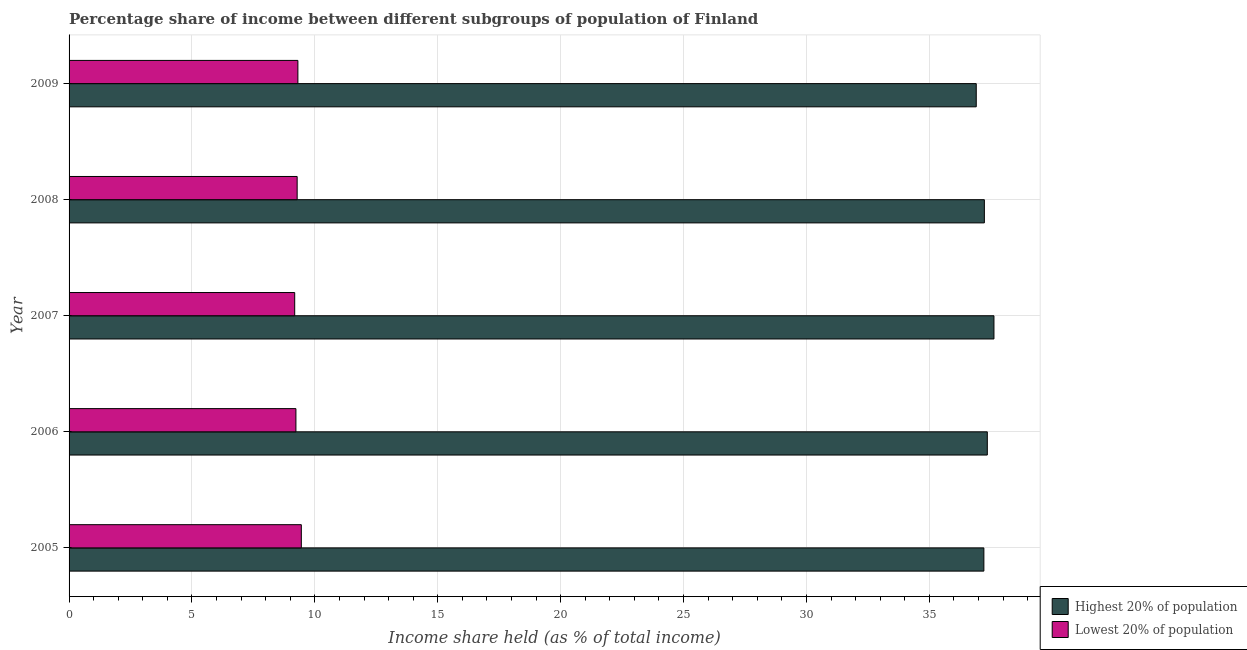What is the income share held by lowest 20% of the population in 2008?
Your answer should be very brief. 9.28. Across all years, what is the maximum income share held by lowest 20% of the population?
Offer a very short reply. 9.45. Across all years, what is the minimum income share held by highest 20% of the population?
Give a very brief answer. 36.91. In which year was the income share held by highest 20% of the population maximum?
Your answer should be compact. 2007. In which year was the income share held by highest 20% of the population minimum?
Keep it short and to the point. 2009. What is the total income share held by highest 20% of the population in the graph?
Your answer should be compact. 186.36. What is the difference between the income share held by highest 20% of the population in 2007 and that in 2008?
Your answer should be compact. 0.39. What is the difference between the income share held by lowest 20% of the population in 2006 and the income share held by highest 20% of the population in 2007?
Provide a short and direct response. -28.4. What is the average income share held by lowest 20% of the population per year?
Your answer should be compact. 9.29. In the year 2005, what is the difference between the income share held by highest 20% of the population and income share held by lowest 20% of the population?
Your answer should be compact. 27.77. What is the ratio of the income share held by lowest 20% of the population in 2006 to that in 2009?
Keep it short and to the point. 0.99. What is the difference between the highest and the second highest income share held by highest 20% of the population?
Offer a very short reply. 0.27. What is the difference between the highest and the lowest income share held by highest 20% of the population?
Your answer should be very brief. 0.72. In how many years, is the income share held by highest 20% of the population greater than the average income share held by highest 20% of the population taken over all years?
Make the answer very short. 2. What does the 2nd bar from the top in 2005 represents?
Offer a terse response. Highest 20% of population. What does the 2nd bar from the bottom in 2006 represents?
Give a very brief answer. Lowest 20% of population. How many years are there in the graph?
Offer a very short reply. 5. Does the graph contain grids?
Provide a short and direct response. Yes. How many legend labels are there?
Make the answer very short. 2. How are the legend labels stacked?
Give a very brief answer. Vertical. What is the title of the graph?
Provide a short and direct response. Percentage share of income between different subgroups of population of Finland. Does "Unregistered firms" appear as one of the legend labels in the graph?
Offer a terse response. No. What is the label or title of the X-axis?
Offer a very short reply. Income share held (as % of total income). What is the label or title of the Y-axis?
Your response must be concise. Year. What is the Income share held (as % of total income) in Highest 20% of population in 2005?
Ensure brevity in your answer.  37.22. What is the Income share held (as % of total income) of Lowest 20% of population in 2005?
Offer a terse response. 9.45. What is the Income share held (as % of total income) in Highest 20% of population in 2006?
Provide a short and direct response. 37.36. What is the Income share held (as % of total income) of Lowest 20% of population in 2006?
Offer a very short reply. 9.23. What is the Income share held (as % of total income) of Highest 20% of population in 2007?
Your response must be concise. 37.63. What is the Income share held (as % of total income) in Lowest 20% of population in 2007?
Give a very brief answer. 9.18. What is the Income share held (as % of total income) of Highest 20% of population in 2008?
Offer a terse response. 37.24. What is the Income share held (as % of total income) of Lowest 20% of population in 2008?
Provide a short and direct response. 9.28. What is the Income share held (as % of total income) of Highest 20% of population in 2009?
Offer a terse response. 36.91. What is the Income share held (as % of total income) of Lowest 20% of population in 2009?
Keep it short and to the point. 9.31. Across all years, what is the maximum Income share held (as % of total income) of Highest 20% of population?
Give a very brief answer. 37.63. Across all years, what is the maximum Income share held (as % of total income) in Lowest 20% of population?
Provide a short and direct response. 9.45. Across all years, what is the minimum Income share held (as % of total income) in Highest 20% of population?
Provide a succinct answer. 36.91. Across all years, what is the minimum Income share held (as % of total income) in Lowest 20% of population?
Offer a terse response. 9.18. What is the total Income share held (as % of total income) of Highest 20% of population in the graph?
Offer a very short reply. 186.36. What is the total Income share held (as % of total income) of Lowest 20% of population in the graph?
Ensure brevity in your answer.  46.45. What is the difference between the Income share held (as % of total income) in Highest 20% of population in 2005 and that in 2006?
Give a very brief answer. -0.14. What is the difference between the Income share held (as % of total income) of Lowest 20% of population in 2005 and that in 2006?
Give a very brief answer. 0.22. What is the difference between the Income share held (as % of total income) of Highest 20% of population in 2005 and that in 2007?
Offer a very short reply. -0.41. What is the difference between the Income share held (as % of total income) of Lowest 20% of population in 2005 and that in 2007?
Provide a succinct answer. 0.27. What is the difference between the Income share held (as % of total income) in Highest 20% of population in 2005 and that in 2008?
Provide a succinct answer. -0.02. What is the difference between the Income share held (as % of total income) of Lowest 20% of population in 2005 and that in 2008?
Provide a succinct answer. 0.17. What is the difference between the Income share held (as % of total income) of Highest 20% of population in 2005 and that in 2009?
Ensure brevity in your answer.  0.31. What is the difference between the Income share held (as % of total income) of Lowest 20% of population in 2005 and that in 2009?
Give a very brief answer. 0.14. What is the difference between the Income share held (as % of total income) of Highest 20% of population in 2006 and that in 2007?
Give a very brief answer. -0.27. What is the difference between the Income share held (as % of total income) in Highest 20% of population in 2006 and that in 2008?
Offer a terse response. 0.12. What is the difference between the Income share held (as % of total income) of Lowest 20% of population in 2006 and that in 2008?
Ensure brevity in your answer.  -0.05. What is the difference between the Income share held (as % of total income) of Highest 20% of population in 2006 and that in 2009?
Your response must be concise. 0.45. What is the difference between the Income share held (as % of total income) in Lowest 20% of population in 2006 and that in 2009?
Keep it short and to the point. -0.08. What is the difference between the Income share held (as % of total income) of Highest 20% of population in 2007 and that in 2008?
Make the answer very short. 0.39. What is the difference between the Income share held (as % of total income) of Lowest 20% of population in 2007 and that in 2008?
Give a very brief answer. -0.1. What is the difference between the Income share held (as % of total income) of Highest 20% of population in 2007 and that in 2009?
Make the answer very short. 0.72. What is the difference between the Income share held (as % of total income) of Lowest 20% of population in 2007 and that in 2009?
Provide a short and direct response. -0.13. What is the difference between the Income share held (as % of total income) in Highest 20% of population in 2008 and that in 2009?
Give a very brief answer. 0.33. What is the difference between the Income share held (as % of total income) in Lowest 20% of population in 2008 and that in 2009?
Offer a terse response. -0.03. What is the difference between the Income share held (as % of total income) in Highest 20% of population in 2005 and the Income share held (as % of total income) in Lowest 20% of population in 2006?
Your answer should be very brief. 27.99. What is the difference between the Income share held (as % of total income) in Highest 20% of population in 2005 and the Income share held (as % of total income) in Lowest 20% of population in 2007?
Ensure brevity in your answer.  28.04. What is the difference between the Income share held (as % of total income) in Highest 20% of population in 2005 and the Income share held (as % of total income) in Lowest 20% of population in 2008?
Offer a terse response. 27.94. What is the difference between the Income share held (as % of total income) in Highest 20% of population in 2005 and the Income share held (as % of total income) in Lowest 20% of population in 2009?
Keep it short and to the point. 27.91. What is the difference between the Income share held (as % of total income) in Highest 20% of population in 2006 and the Income share held (as % of total income) in Lowest 20% of population in 2007?
Make the answer very short. 28.18. What is the difference between the Income share held (as % of total income) of Highest 20% of population in 2006 and the Income share held (as % of total income) of Lowest 20% of population in 2008?
Make the answer very short. 28.08. What is the difference between the Income share held (as % of total income) of Highest 20% of population in 2006 and the Income share held (as % of total income) of Lowest 20% of population in 2009?
Give a very brief answer. 28.05. What is the difference between the Income share held (as % of total income) in Highest 20% of population in 2007 and the Income share held (as % of total income) in Lowest 20% of population in 2008?
Keep it short and to the point. 28.35. What is the difference between the Income share held (as % of total income) of Highest 20% of population in 2007 and the Income share held (as % of total income) of Lowest 20% of population in 2009?
Your answer should be compact. 28.32. What is the difference between the Income share held (as % of total income) in Highest 20% of population in 2008 and the Income share held (as % of total income) in Lowest 20% of population in 2009?
Provide a succinct answer. 27.93. What is the average Income share held (as % of total income) in Highest 20% of population per year?
Ensure brevity in your answer.  37.27. What is the average Income share held (as % of total income) in Lowest 20% of population per year?
Your answer should be compact. 9.29. In the year 2005, what is the difference between the Income share held (as % of total income) in Highest 20% of population and Income share held (as % of total income) in Lowest 20% of population?
Give a very brief answer. 27.77. In the year 2006, what is the difference between the Income share held (as % of total income) in Highest 20% of population and Income share held (as % of total income) in Lowest 20% of population?
Give a very brief answer. 28.13. In the year 2007, what is the difference between the Income share held (as % of total income) in Highest 20% of population and Income share held (as % of total income) in Lowest 20% of population?
Give a very brief answer. 28.45. In the year 2008, what is the difference between the Income share held (as % of total income) in Highest 20% of population and Income share held (as % of total income) in Lowest 20% of population?
Provide a short and direct response. 27.96. In the year 2009, what is the difference between the Income share held (as % of total income) in Highest 20% of population and Income share held (as % of total income) in Lowest 20% of population?
Offer a terse response. 27.6. What is the ratio of the Income share held (as % of total income) of Lowest 20% of population in 2005 to that in 2006?
Offer a terse response. 1.02. What is the ratio of the Income share held (as % of total income) in Highest 20% of population in 2005 to that in 2007?
Keep it short and to the point. 0.99. What is the ratio of the Income share held (as % of total income) of Lowest 20% of population in 2005 to that in 2007?
Give a very brief answer. 1.03. What is the ratio of the Income share held (as % of total income) of Highest 20% of population in 2005 to that in 2008?
Offer a terse response. 1. What is the ratio of the Income share held (as % of total income) of Lowest 20% of population in 2005 to that in 2008?
Ensure brevity in your answer.  1.02. What is the ratio of the Income share held (as % of total income) in Highest 20% of population in 2005 to that in 2009?
Give a very brief answer. 1.01. What is the ratio of the Income share held (as % of total income) in Highest 20% of population in 2006 to that in 2007?
Your answer should be compact. 0.99. What is the ratio of the Income share held (as % of total income) in Lowest 20% of population in 2006 to that in 2007?
Make the answer very short. 1.01. What is the ratio of the Income share held (as % of total income) of Lowest 20% of population in 2006 to that in 2008?
Provide a succinct answer. 0.99. What is the ratio of the Income share held (as % of total income) of Highest 20% of population in 2006 to that in 2009?
Your answer should be very brief. 1.01. What is the ratio of the Income share held (as % of total income) of Highest 20% of population in 2007 to that in 2008?
Make the answer very short. 1.01. What is the ratio of the Income share held (as % of total income) of Lowest 20% of population in 2007 to that in 2008?
Offer a terse response. 0.99. What is the ratio of the Income share held (as % of total income) in Highest 20% of population in 2007 to that in 2009?
Your response must be concise. 1.02. What is the ratio of the Income share held (as % of total income) of Highest 20% of population in 2008 to that in 2009?
Your answer should be compact. 1.01. What is the difference between the highest and the second highest Income share held (as % of total income) of Highest 20% of population?
Your answer should be compact. 0.27. What is the difference between the highest and the second highest Income share held (as % of total income) in Lowest 20% of population?
Provide a succinct answer. 0.14. What is the difference between the highest and the lowest Income share held (as % of total income) of Highest 20% of population?
Your response must be concise. 0.72. What is the difference between the highest and the lowest Income share held (as % of total income) in Lowest 20% of population?
Your answer should be very brief. 0.27. 